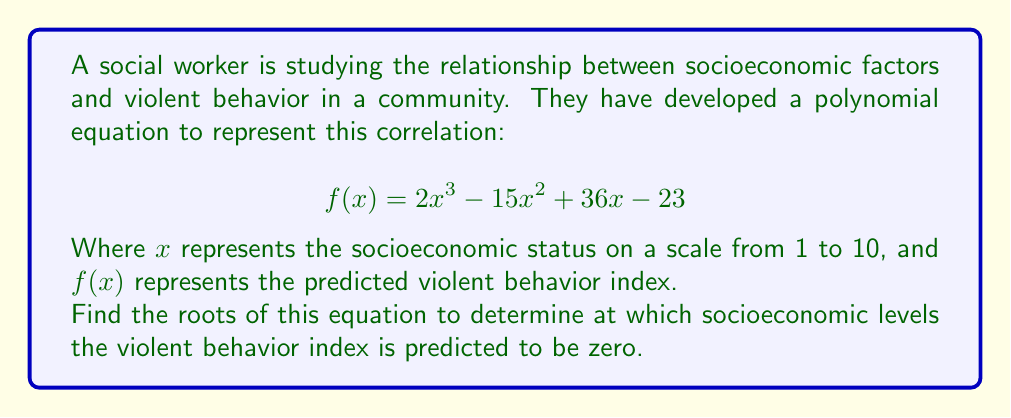Show me your answer to this math problem. To solve this polynomial equation, we need to factor it and find the values of $x$ that make $f(x) = 0$.

1) First, let's check if there are any rational roots using the rational root theorem. The possible rational roots are the factors of the constant term: $\pm 1, \pm 23$.

2) By testing these values, we find that $x = 1$ is a root of the equation.

3) We can factor out $(x - 1)$:

   $$2x^3 - 15x^2 + 36x - 23 = (x - 1)(2x^2 - 13x + 23)$$

4) Now we need to solve the quadratic equation $2x^2 - 13x + 23 = 0$

5) We can use the quadratic formula: $x = \frac{-b \pm \sqrt{b^2 - 4ac}}{2a}$

   Where $a = 2$, $b = -13$, and $c = 23$

6) Substituting these values:

   $$x = \frac{13 \pm \sqrt{(-13)^2 - 4(2)(23)}}{2(2)}$$
   $$x = \frac{13 \pm \sqrt{169 - 184}}{4}$$
   $$x = \frac{13 \pm \sqrt{-15}}{4}$$

7) Since the discriminant is negative, the other two roots are complex conjugates.

Therefore, the only real root of the equation is $x = 1$.
Answer: The equation has only one real root: $x = 1$. This suggests that the violent behavior index is predicted to be zero when the socioeconomic status is 1 on the given scale. 